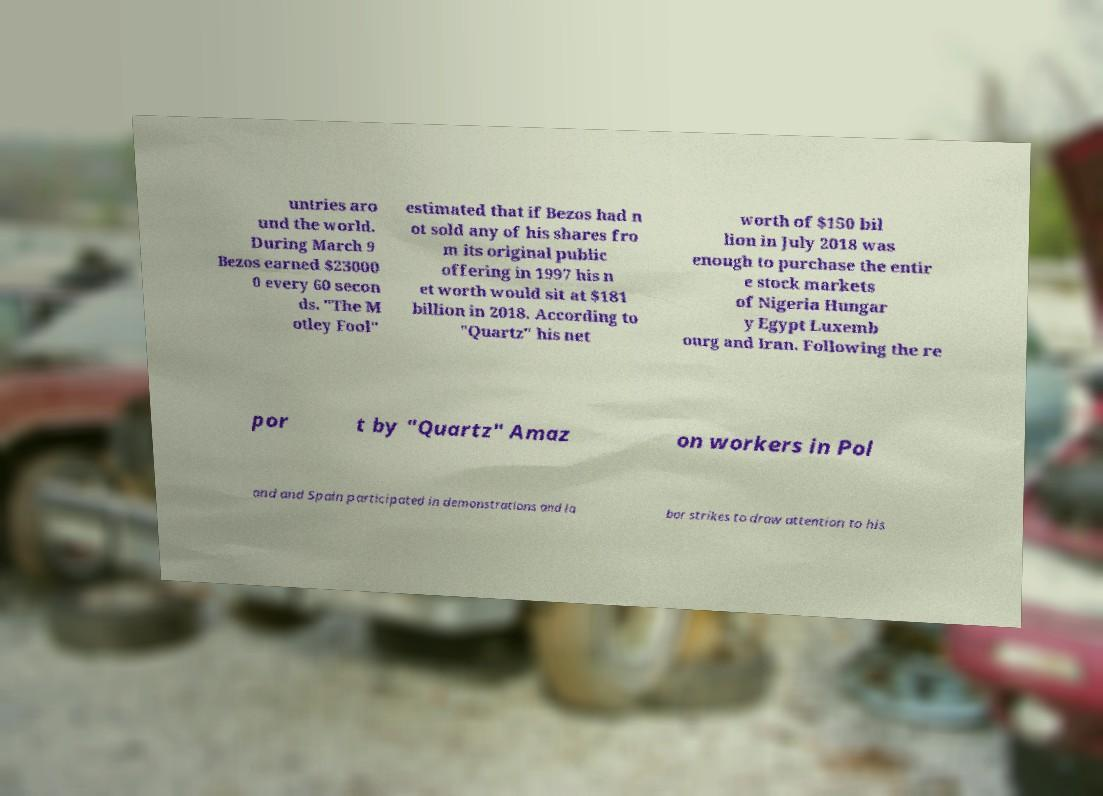For documentation purposes, I need the text within this image transcribed. Could you provide that? untries aro und the world. During March 9 Bezos earned $23000 0 every 60 secon ds. "The M otley Fool" estimated that if Bezos had n ot sold any of his shares fro m its original public offering in 1997 his n et worth would sit at $181 billion in 2018. According to "Quartz" his net worth of $150 bil lion in July 2018 was enough to purchase the entir e stock markets of Nigeria Hungar y Egypt Luxemb ourg and Iran. Following the re por t by "Quartz" Amaz on workers in Pol and and Spain participated in demonstrations and la bor strikes to draw attention to his 